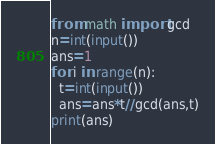Convert code to text. <code><loc_0><loc_0><loc_500><loc_500><_Python_>from math import gcd
n=int(input())
ans=1
for i in range(n):
  t=int(input())
  ans=ans*t//gcd(ans,t)
print(ans)</code> 